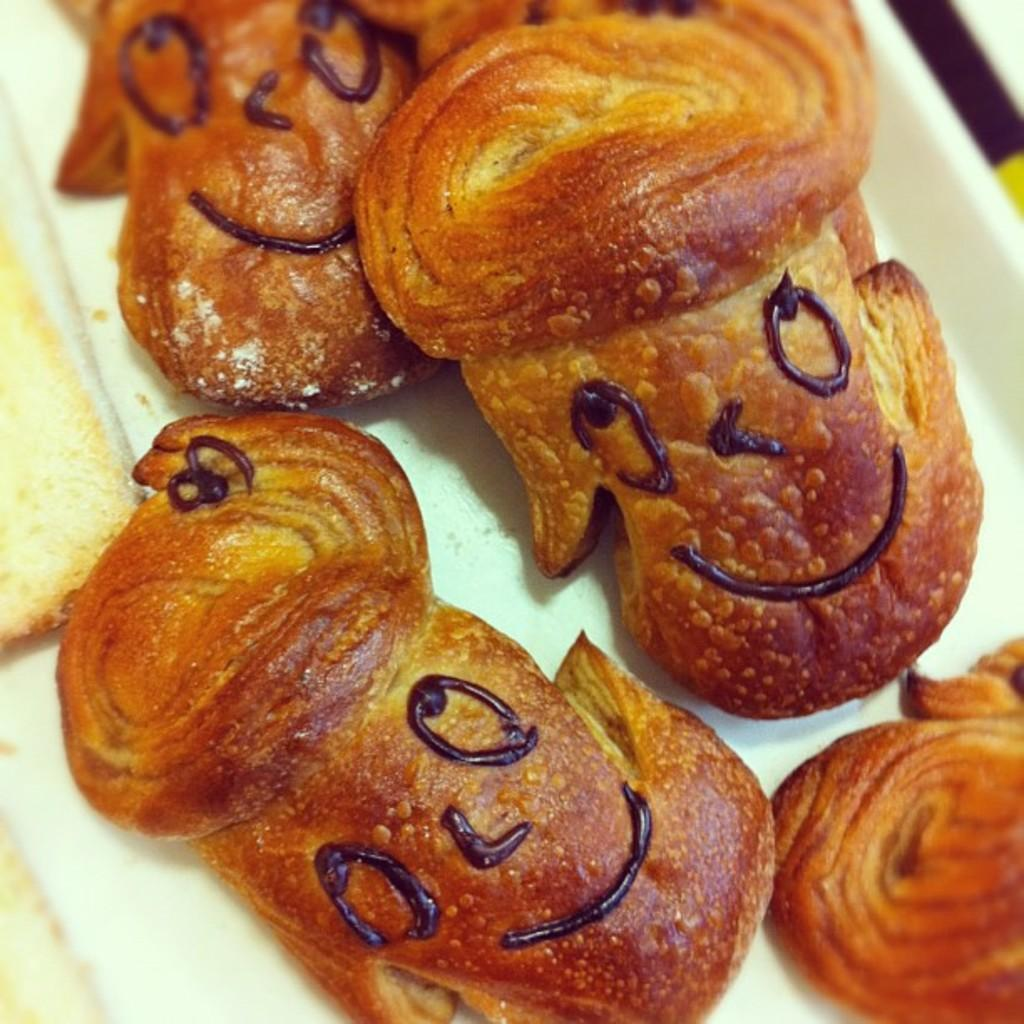What is on the plate in the image? There is food on a plate in the image. What type of horn can be seen playing music in the image? There is no horn or music present in the image; it only features a plate with food on it. 